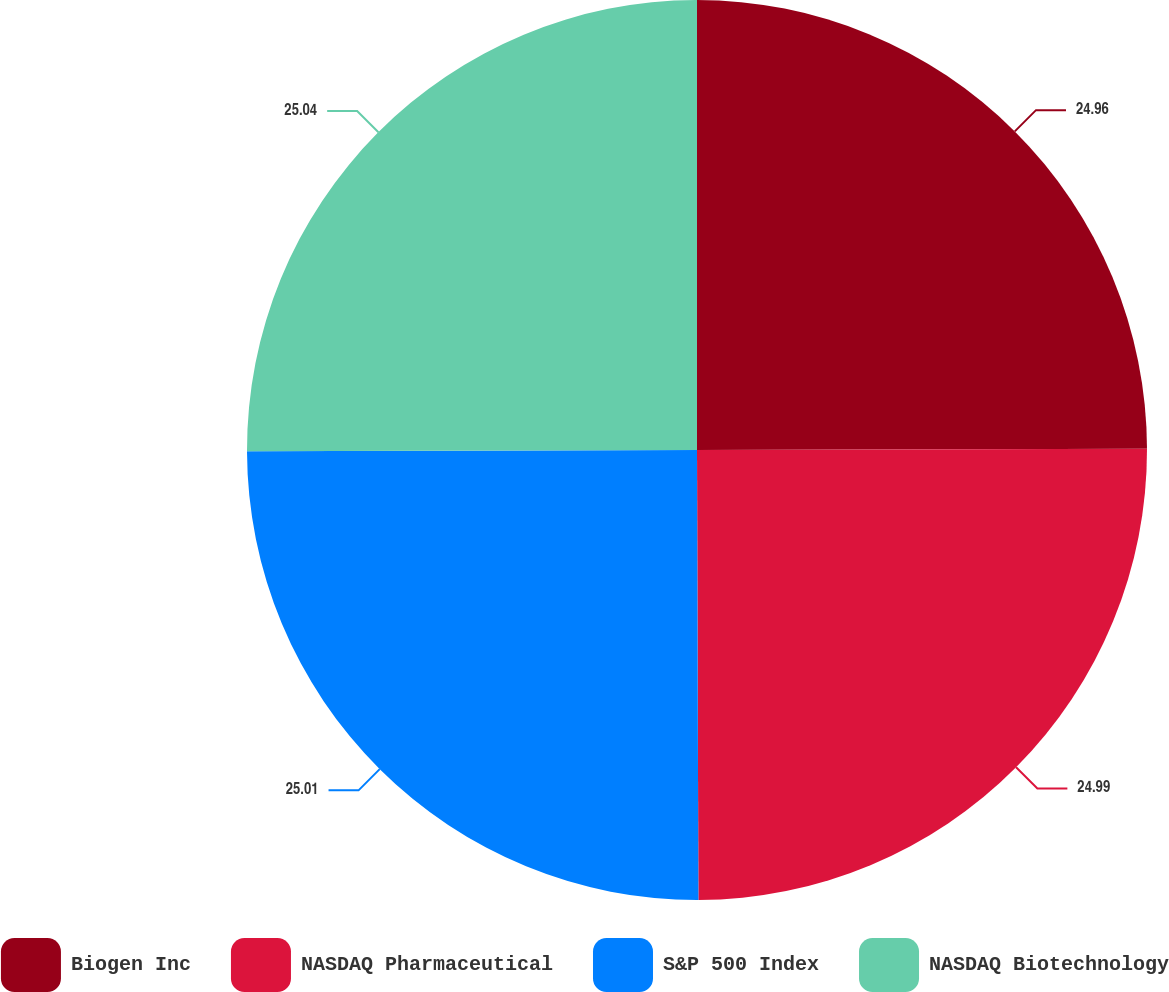<chart> <loc_0><loc_0><loc_500><loc_500><pie_chart><fcel>Biogen Inc<fcel>NASDAQ Pharmaceutical<fcel>S&P 500 Index<fcel>NASDAQ Biotechnology<nl><fcel>24.96%<fcel>24.99%<fcel>25.01%<fcel>25.04%<nl></chart> 